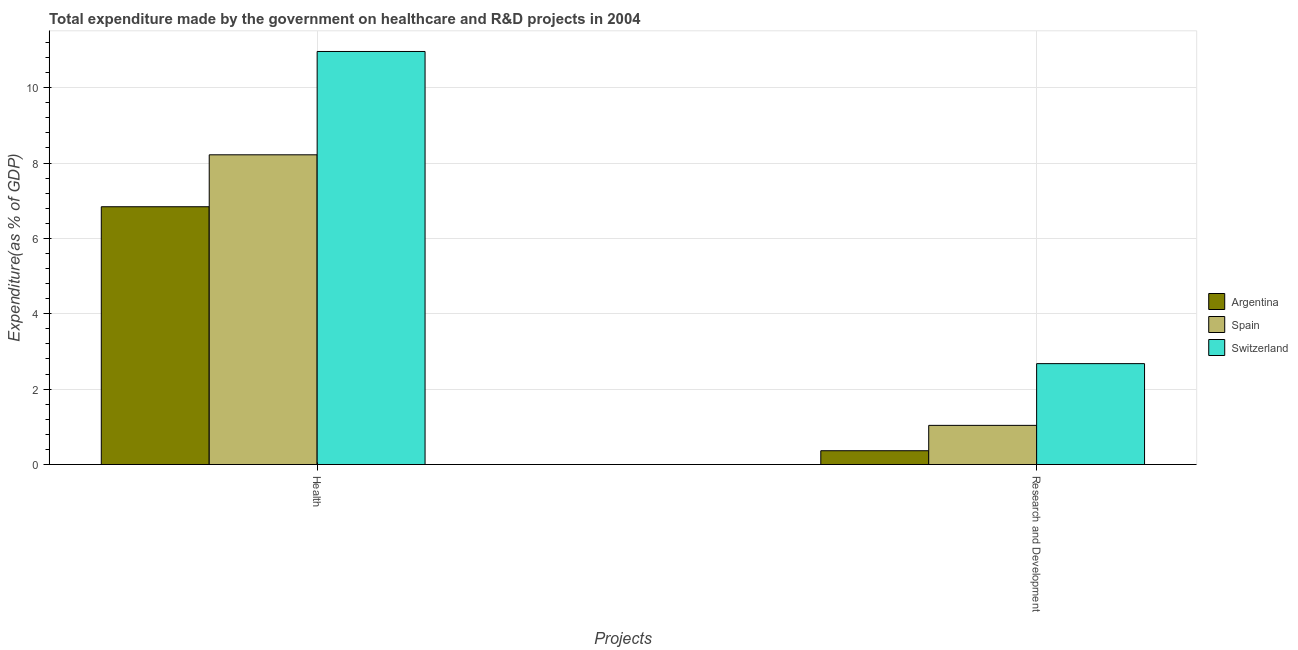Are the number of bars on each tick of the X-axis equal?
Your response must be concise. Yes. How many bars are there on the 2nd tick from the left?
Offer a terse response. 3. How many bars are there on the 1st tick from the right?
Offer a terse response. 3. What is the label of the 2nd group of bars from the left?
Your answer should be very brief. Research and Development. What is the expenditure in healthcare in Argentina?
Your answer should be very brief. 6.84. Across all countries, what is the maximum expenditure in r&d?
Your answer should be very brief. 2.68. Across all countries, what is the minimum expenditure in healthcare?
Provide a succinct answer. 6.84. In which country was the expenditure in healthcare maximum?
Offer a very short reply. Switzerland. In which country was the expenditure in healthcare minimum?
Keep it short and to the point. Argentina. What is the total expenditure in r&d in the graph?
Offer a very short reply. 4.08. What is the difference between the expenditure in healthcare in Switzerland and that in Argentina?
Offer a very short reply. 4.12. What is the difference between the expenditure in healthcare in Argentina and the expenditure in r&d in Spain?
Give a very brief answer. 5.8. What is the average expenditure in healthcare per country?
Provide a succinct answer. 8.67. What is the difference between the expenditure in healthcare and expenditure in r&d in Spain?
Make the answer very short. 7.18. What is the ratio of the expenditure in healthcare in Spain to that in Argentina?
Offer a very short reply. 1.2. In how many countries, is the expenditure in r&d greater than the average expenditure in r&d taken over all countries?
Provide a succinct answer. 1. What does the 2nd bar from the right in Research and Development represents?
Make the answer very short. Spain. How many countries are there in the graph?
Provide a short and direct response. 3. What is the difference between two consecutive major ticks on the Y-axis?
Ensure brevity in your answer.  2. Does the graph contain any zero values?
Keep it short and to the point. No. Where does the legend appear in the graph?
Your answer should be compact. Center right. What is the title of the graph?
Provide a succinct answer. Total expenditure made by the government on healthcare and R&D projects in 2004. Does "Rwanda" appear as one of the legend labels in the graph?
Your answer should be very brief. No. What is the label or title of the X-axis?
Provide a short and direct response. Projects. What is the label or title of the Y-axis?
Give a very brief answer. Expenditure(as % of GDP). What is the Expenditure(as % of GDP) of Argentina in Health?
Provide a short and direct response. 6.84. What is the Expenditure(as % of GDP) of Spain in Health?
Your response must be concise. 8.22. What is the Expenditure(as % of GDP) of Switzerland in Health?
Your answer should be very brief. 10.96. What is the Expenditure(as % of GDP) in Argentina in Research and Development?
Provide a succinct answer. 0.37. What is the Expenditure(as % of GDP) in Spain in Research and Development?
Offer a terse response. 1.04. What is the Expenditure(as % of GDP) of Switzerland in Research and Development?
Ensure brevity in your answer.  2.68. Across all Projects, what is the maximum Expenditure(as % of GDP) in Argentina?
Offer a terse response. 6.84. Across all Projects, what is the maximum Expenditure(as % of GDP) in Spain?
Your answer should be compact. 8.22. Across all Projects, what is the maximum Expenditure(as % of GDP) of Switzerland?
Provide a short and direct response. 10.96. Across all Projects, what is the minimum Expenditure(as % of GDP) of Argentina?
Your answer should be very brief. 0.37. Across all Projects, what is the minimum Expenditure(as % of GDP) in Spain?
Your answer should be compact. 1.04. Across all Projects, what is the minimum Expenditure(as % of GDP) of Switzerland?
Offer a terse response. 2.68. What is the total Expenditure(as % of GDP) in Argentina in the graph?
Provide a short and direct response. 7.21. What is the total Expenditure(as % of GDP) in Spain in the graph?
Offer a terse response. 9.26. What is the total Expenditure(as % of GDP) in Switzerland in the graph?
Make the answer very short. 13.64. What is the difference between the Expenditure(as % of GDP) of Argentina in Health and that in Research and Development?
Your answer should be very brief. 6.47. What is the difference between the Expenditure(as % of GDP) in Spain in Health and that in Research and Development?
Keep it short and to the point. 7.18. What is the difference between the Expenditure(as % of GDP) of Switzerland in Health and that in Research and Development?
Your answer should be very brief. 8.28. What is the difference between the Expenditure(as % of GDP) of Argentina in Health and the Expenditure(as % of GDP) of Spain in Research and Development?
Your answer should be compact. 5.8. What is the difference between the Expenditure(as % of GDP) of Argentina in Health and the Expenditure(as % of GDP) of Switzerland in Research and Development?
Your answer should be very brief. 4.16. What is the difference between the Expenditure(as % of GDP) of Spain in Health and the Expenditure(as % of GDP) of Switzerland in Research and Development?
Keep it short and to the point. 5.54. What is the average Expenditure(as % of GDP) of Argentina per Projects?
Give a very brief answer. 3.6. What is the average Expenditure(as % of GDP) in Spain per Projects?
Offer a very short reply. 4.63. What is the average Expenditure(as % of GDP) of Switzerland per Projects?
Make the answer very short. 6.82. What is the difference between the Expenditure(as % of GDP) of Argentina and Expenditure(as % of GDP) of Spain in Health?
Your answer should be compact. -1.38. What is the difference between the Expenditure(as % of GDP) of Argentina and Expenditure(as % of GDP) of Switzerland in Health?
Make the answer very short. -4.12. What is the difference between the Expenditure(as % of GDP) of Spain and Expenditure(as % of GDP) of Switzerland in Health?
Your answer should be compact. -2.74. What is the difference between the Expenditure(as % of GDP) of Argentina and Expenditure(as % of GDP) of Spain in Research and Development?
Your answer should be very brief. -0.67. What is the difference between the Expenditure(as % of GDP) of Argentina and Expenditure(as % of GDP) of Switzerland in Research and Development?
Offer a terse response. -2.31. What is the difference between the Expenditure(as % of GDP) in Spain and Expenditure(as % of GDP) in Switzerland in Research and Development?
Your response must be concise. -1.64. What is the ratio of the Expenditure(as % of GDP) of Argentina in Health to that in Research and Development?
Provide a succinct answer. 18.71. What is the ratio of the Expenditure(as % of GDP) in Spain in Health to that in Research and Development?
Provide a succinct answer. 7.91. What is the ratio of the Expenditure(as % of GDP) in Switzerland in Health to that in Research and Development?
Give a very brief answer. 4.09. What is the difference between the highest and the second highest Expenditure(as % of GDP) in Argentina?
Your answer should be very brief. 6.47. What is the difference between the highest and the second highest Expenditure(as % of GDP) of Spain?
Give a very brief answer. 7.18. What is the difference between the highest and the second highest Expenditure(as % of GDP) in Switzerland?
Offer a very short reply. 8.28. What is the difference between the highest and the lowest Expenditure(as % of GDP) in Argentina?
Your answer should be compact. 6.47. What is the difference between the highest and the lowest Expenditure(as % of GDP) in Spain?
Provide a short and direct response. 7.18. What is the difference between the highest and the lowest Expenditure(as % of GDP) in Switzerland?
Offer a very short reply. 8.28. 